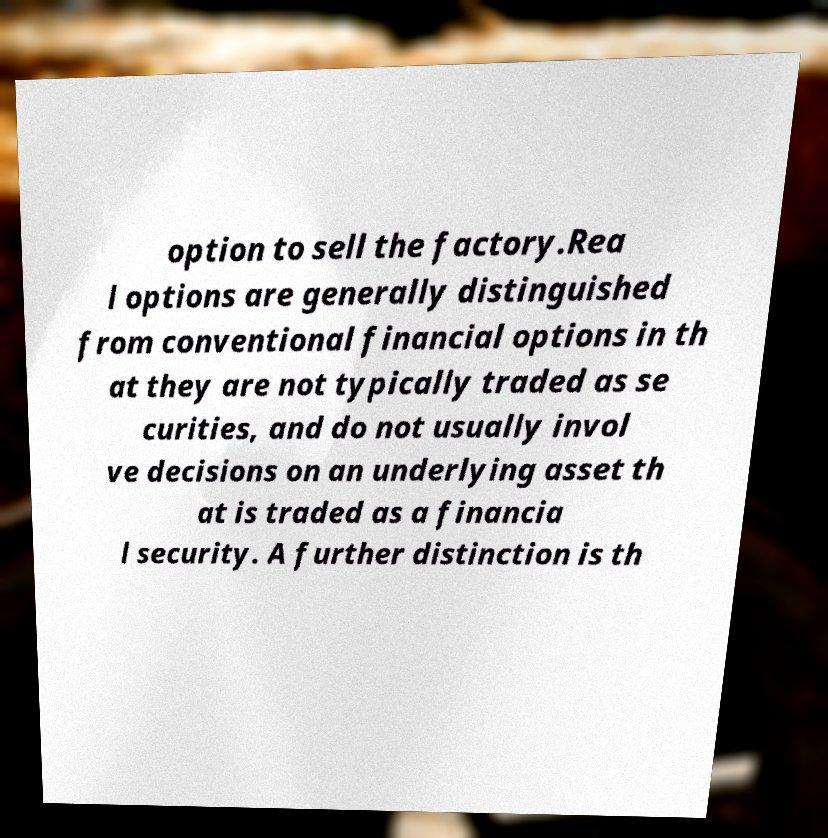Please read and relay the text visible in this image. What does it say? option to sell the factory.Rea l options are generally distinguished from conventional financial options in th at they are not typically traded as se curities, and do not usually invol ve decisions on an underlying asset th at is traded as a financia l security. A further distinction is th 